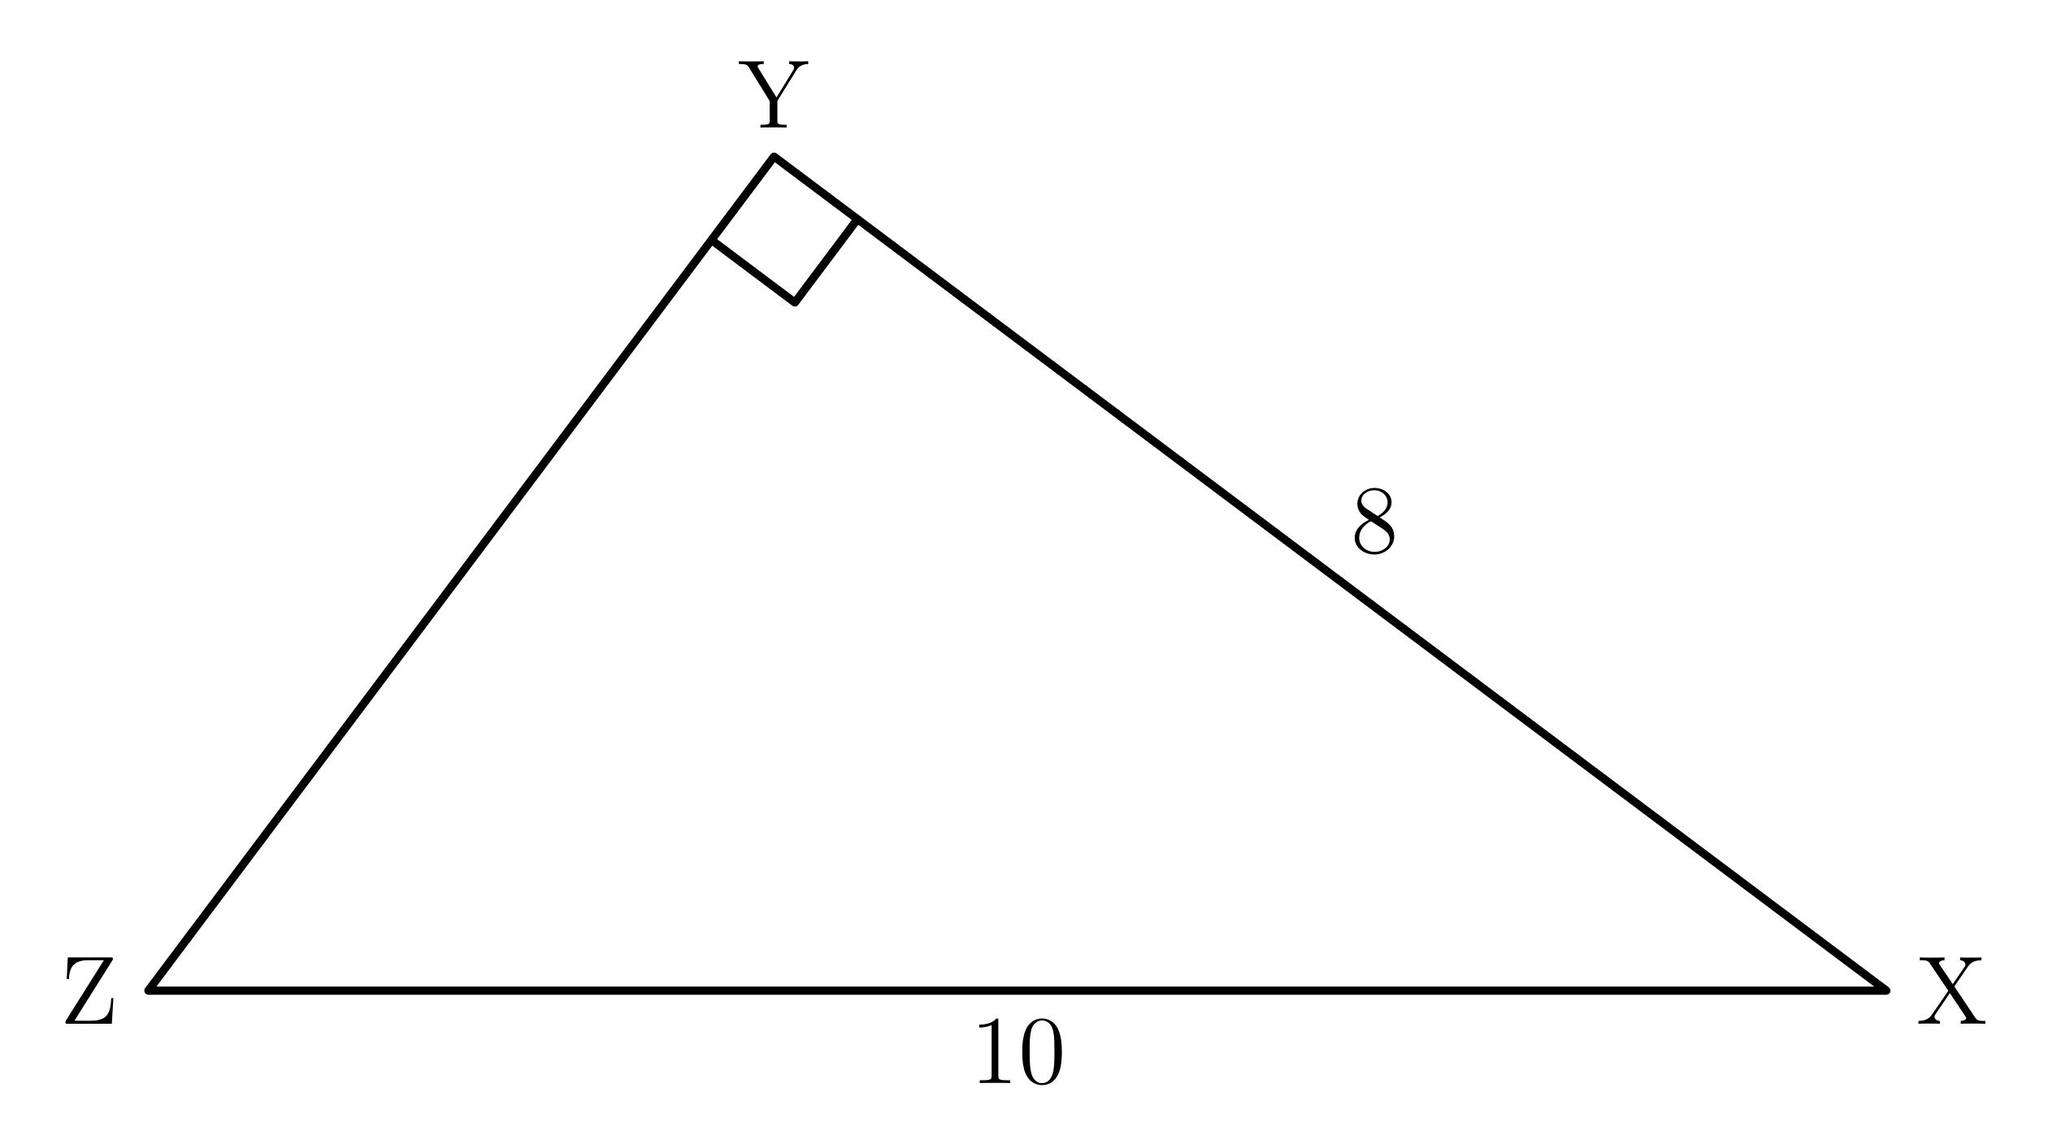Can you determine the length of side YZ in triangle XYZ? Yes, in the right triangle XYZ, the length of side YZ, which is the hypotenuse, can be found using the Pythagorean theorem. The lengths of the other two sides are given, with XY being 10 units and XZ being 8 units. Using the formula $c^2 = a^2 + b^2$, where c is the hypotenuse and a and b are the other two sides, the length of YZ is the square root of $(10^2 + 8^2)$, which equals the square root of 164, or approximately 12.81 units. 